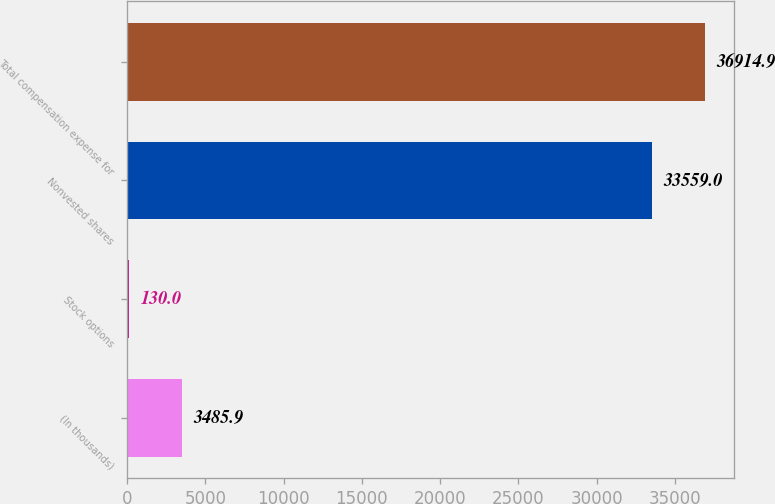Convert chart. <chart><loc_0><loc_0><loc_500><loc_500><bar_chart><fcel>(In thousands)<fcel>Stock options<fcel>Nonvested shares<fcel>Total compensation expense for<nl><fcel>3485.9<fcel>130<fcel>33559<fcel>36914.9<nl></chart> 